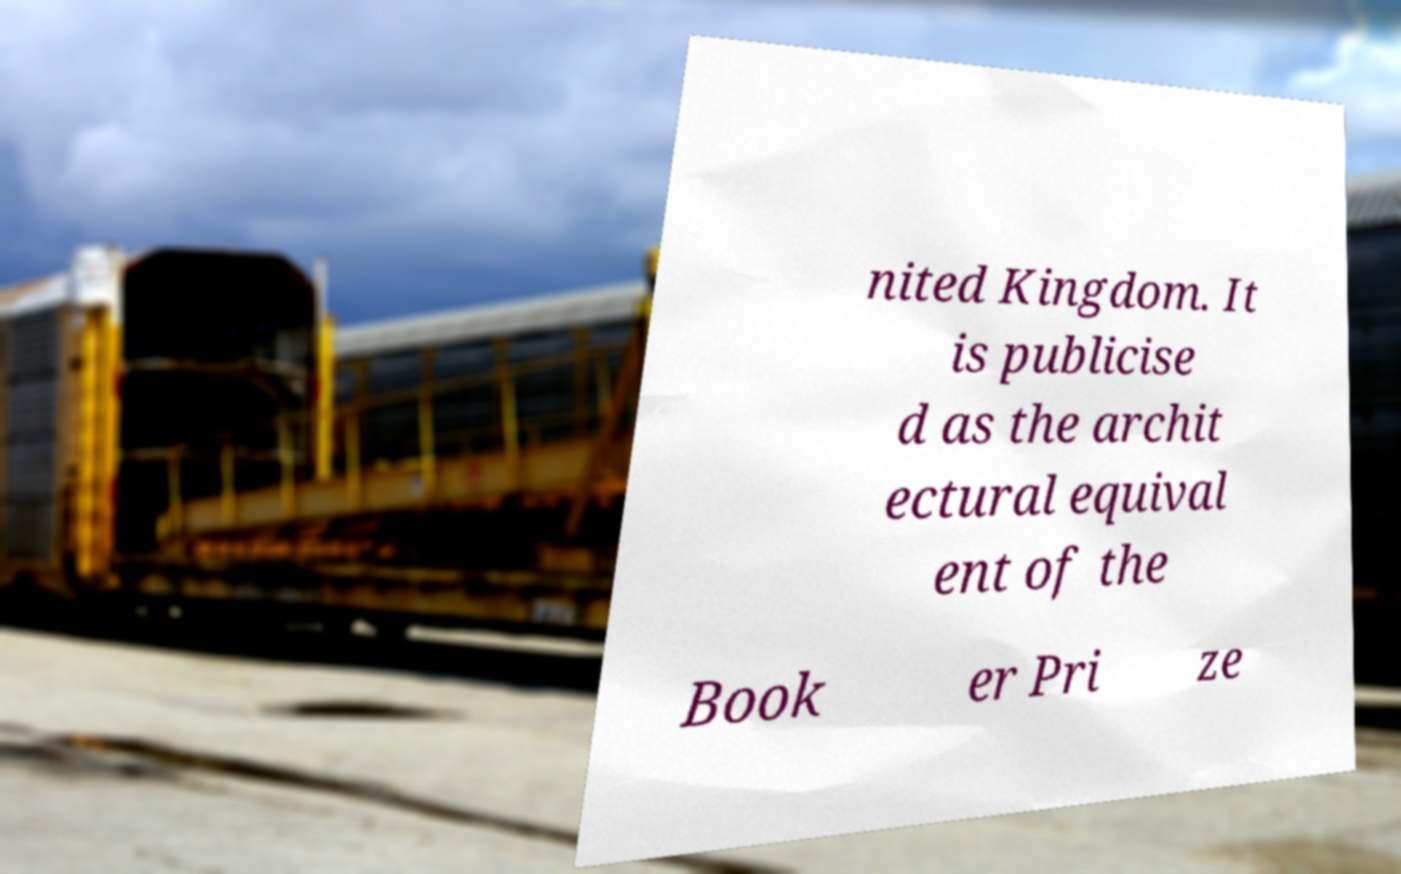Could you extract and type out the text from this image? nited Kingdom. It is publicise d as the archit ectural equival ent of the Book er Pri ze 